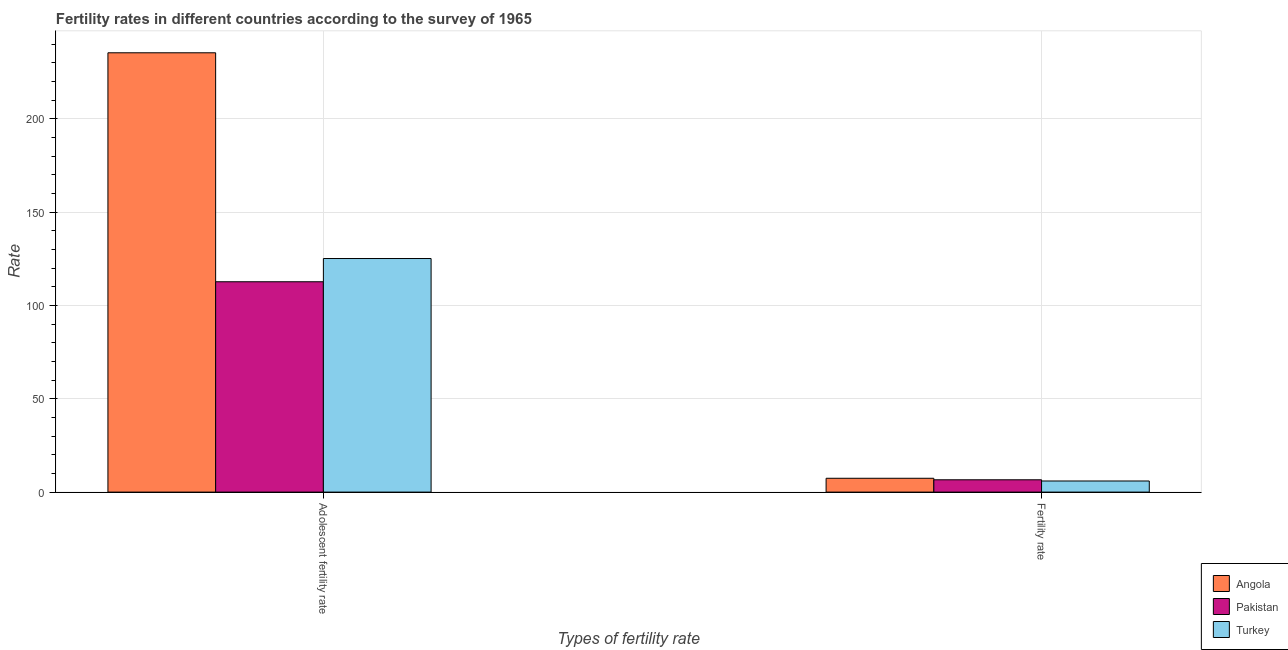Are the number of bars on each tick of the X-axis equal?
Offer a terse response. Yes. How many bars are there on the 1st tick from the right?
Provide a succinct answer. 3. What is the label of the 2nd group of bars from the left?
Offer a terse response. Fertility rate. What is the adolescent fertility rate in Angola?
Provide a succinct answer. 235.32. Across all countries, what is the maximum fertility rate?
Offer a very short reply. 7.41. Across all countries, what is the minimum adolescent fertility rate?
Provide a short and direct response. 112.67. In which country was the adolescent fertility rate maximum?
Keep it short and to the point. Angola. In which country was the adolescent fertility rate minimum?
Give a very brief answer. Pakistan. What is the total fertility rate in the graph?
Provide a short and direct response. 19.96. What is the difference between the fertility rate in Angola and that in Turkey?
Make the answer very short. 1.46. What is the difference between the adolescent fertility rate in Turkey and the fertility rate in Angola?
Your answer should be compact. 117.71. What is the average fertility rate per country?
Make the answer very short. 6.65. What is the difference between the adolescent fertility rate and fertility rate in Angola?
Provide a short and direct response. 227.91. What is the ratio of the adolescent fertility rate in Pakistan to that in Turkey?
Provide a succinct answer. 0.9. Is the adolescent fertility rate in Angola less than that in Pakistan?
Offer a very short reply. No. What does the 1st bar from the left in Fertility rate represents?
Offer a terse response. Angola. What does the 2nd bar from the right in Adolescent fertility rate represents?
Give a very brief answer. Pakistan. How many countries are there in the graph?
Your answer should be very brief. 3. What is the difference between two consecutive major ticks on the Y-axis?
Your response must be concise. 50. Are the values on the major ticks of Y-axis written in scientific E-notation?
Provide a succinct answer. No. Where does the legend appear in the graph?
Give a very brief answer. Bottom right. How many legend labels are there?
Ensure brevity in your answer.  3. How are the legend labels stacked?
Give a very brief answer. Vertical. What is the title of the graph?
Offer a terse response. Fertility rates in different countries according to the survey of 1965. What is the label or title of the X-axis?
Give a very brief answer. Types of fertility rate. What is the label or title of the Y-axis?
Offer a terse response. Rate. What is the Rate in Angola in Adolescent fertility rate?
Your answer should be compact. 235.32. What is the Rate of Pakistan in Adolescent fertility rate?
Your answer should be compact. 112.67. What is the Rate of Turkey in Adolescent fertility rate?
Your answer should be compact. 125.11. What is the Rate in Angola in Fertility rate?
Offer a terse response. 7.41. What is the Rate of Pakistan in Fertility rate?
Provide a succinct answer. 6.6. What is the Rate in Turkey in Fertility rate?
Offer a terse response. 5.95. Across all Types of fertility rate, what is the maximum Rate of Angola?
Keep it short and to the point. 235.32. Across all Types of fertility rate, what is the maximum Rate in Pakistan?
Offer a very short reply. 112.67. Across all Types of fertility rate, what is the maximum Rate of Turkey?
Offer a very short reply. 125.11. Across all Types of fertility rate, what is the minimum Rate of Angola?
Offer a very short reply. 7.41. Across all Types of fertility rate, what is the minimum Rate in Turkey?
Keep it short and to the point. 5.95. What is the total Rate in Angola in the graph?
Offer a very short reply. 242.73. What is the total Rate of Pakistan in the graph?
Your response must be concise. 119.28. What is the total Rate in Turkey in the graph?
Ensure brevity in your answer.  131.07. What is the difference between the Rate in Angola in Adolescent fertility rate and that in Fertility rate?
Offer a very short reply. 227.91. What is the difference between the Rate in Pakistan in Adolescent fertility rate and that in Fertility rate?
Offer a very short reply. 106.08. What is the difference between the Rate of Turkey in Adolescent fertility rate and that in Fertility rate?
Offer a very short reply. 119.16. What is the difference between the Rate of Angola in Adolescent fertility rate and the Rate of Pakistan in Fertility rate?
Make the answer very short. 228.72. What is the difference between the Rate of Angola in Adolescent fertility rate and the Rate of Turkey in Fertility rate?
Your answer should be compact. 229.37. What is the difference between the Rate in Pakistan in Adolescent fertility rate and the Rate in Turkey in Fertility rate?
Give a very brief answer. 106.72. What is the average Rate in Angola per Types of fertility rate?
Your response must be concise. 121.36. What is the average Rate of Pakistan per Types of fertility rate?
Your answer should be very brief. 59.64. What is the average Rate in Turkey per Types of fertility rate?
Ensure brevity in your answer.  65.53. What is the difference between the Rate in Angola and Rate in Pakistan in Adolescent fertility rate?
Your answer should be compact. 122.64. What is the difference between the Rate in Angola and Rate in Turkey in Adolescent fertility rate?
Ensure brevity in your answer.  110.2. What is the difference between the Rate of Pakistan and Rate of Turkey in Adolescent fertility rate?
Provide a succinct answer. -12.44. What is the difference between the Rate of Angola and Rate of Pakistan in Fertility rate?
Keep it short and to the point. 0.81. What is the difference between the Rate in Angola and Rate in Turkey in Fertility rate?
Offer a very short reply. 1.46. What is the difference between the Rate in Pakistan and Rate in Turkey in Fertility rate?
Your response must be concise. 0.65. What is the ratio of the Rate of Angola in Adolescent fertility rate to that in Fertility rate?
Keep it short and to the point. 31.77. What is the ratio of the Rate of Pakistan in Adolescent fertility rate to that in Fertility rate?
Give a very brief answer. 17.07. What is the ratio of the Rate of Turkey in Adolescent fertility rate to that in Fertility rate?
Provide a short and direct response. 21.02. What is the difference between the highest and the second highest Rate in Angola?
Offer a terse response. 227.91. What is the difference between the highest and the second highest Rate in Pakistan?
Ensure brevity in your answer.  106.08. What is the difference between the highest and the second highest Rate in Turkey?
Make the answer very short. 119.16. What is the difference between the highest and the lowest Rate in Angola?
Your answer should be compact. 227.91. What is the difference between the highest and the lowest Rate in Pakistan?
Your answer should be compact. 106.08. What is the difference between the highest and the lowest Rate of Turkey?
Keep it short and to the point. 119.16. 